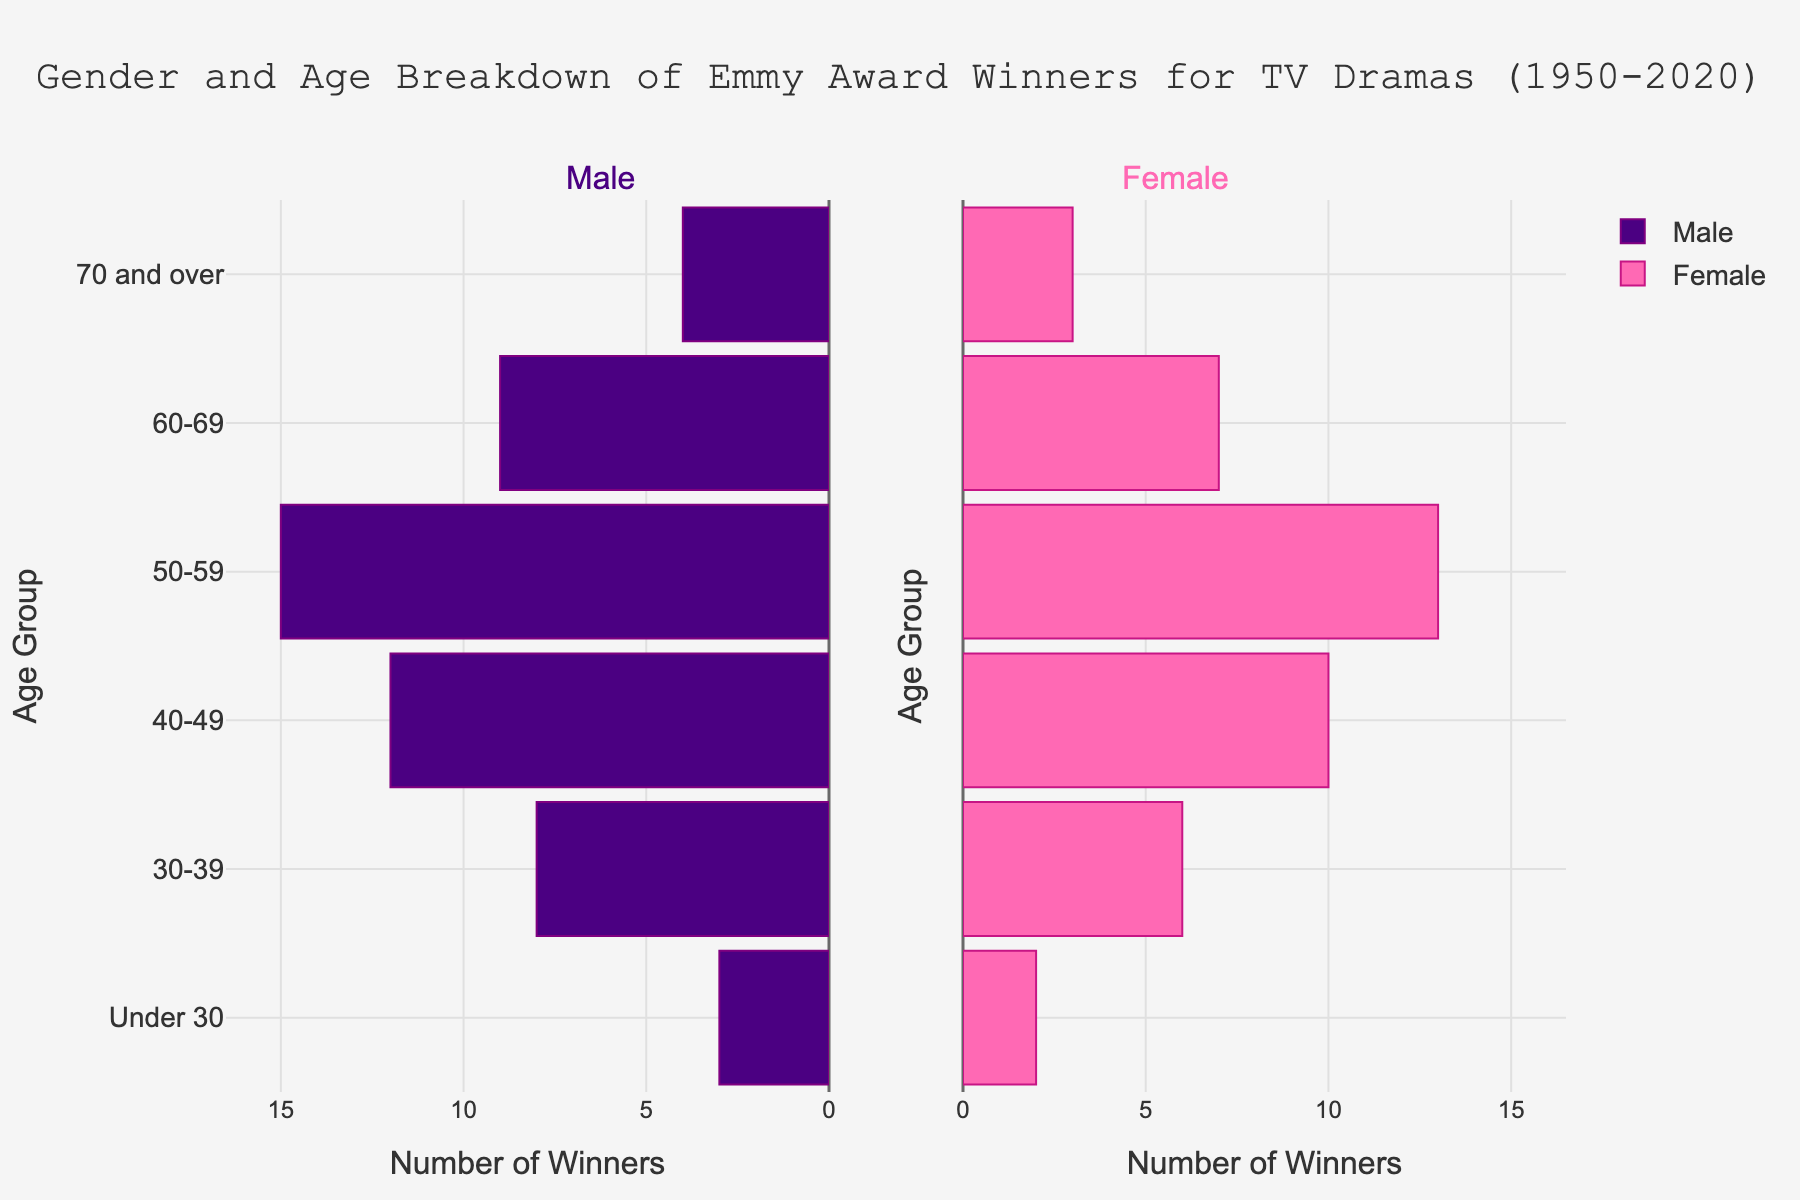Which gender has a broader presence in the 40-49 age group? By comparing the lengths of the bars for the 40-49 age group, the male bar extends further than the female bar. This shows that males have a broader presence in this age group.
Answer: Males What is the total number of male winners aged 30-59? Add the male winners in the 30-39, 40-49, and 50-59 age groups (8 + 12 + 15 = 35).
Answer: 35 How does the number of female winners under 30 compare to that of those aged 70 and over? By checking the lengths of the bars, there are 2 female winners under 30 and 3 female winners aged 70 and over. Therefore, the number of female winners aged 70 and over is greater.
Answer: The number of female winners aged 70 and over is greater In which age group do females outnumber males by the largest margin? Subtract the number of male winners from female winners in each age group and compare the results. The age group 40-49 has the largest difference (10 - 12 = -2).
Answer: 40-49 What is the combined number of male and female winners in the age group 50-59? Sum the male winners (15) and female winners (13) in the 50-59 age group.
Answer: 28 Which age group has the smallest difference in the number of male and female winners? Calculate the difference in winners for each age group. The smallest difference is in the "Under 30" age group with a difference of (3 - 2 = 1).
Answer: Under 30 What is the overall trend in the number of male winners as age increases? The lengths of the bars indicate that the number of male winners generally decreases as the age groups progress from younger to older.
Answer: Decreasing trend Who won more awards in the 60-69 age group, males or females? Compare the number of male (9) and female (7) winners in the 60-69 age group. Since the number of male winners is higher, males won more awards.
Answer: Males What is the approximate ratio of male to female winners in the age group 30-39? Divide the number of male winners (8) by the number of female winners (6) in the 30-39 age group to get the ratio (8:6 or approximately 1.33:1).
Answer: Approximately 1.33:1 